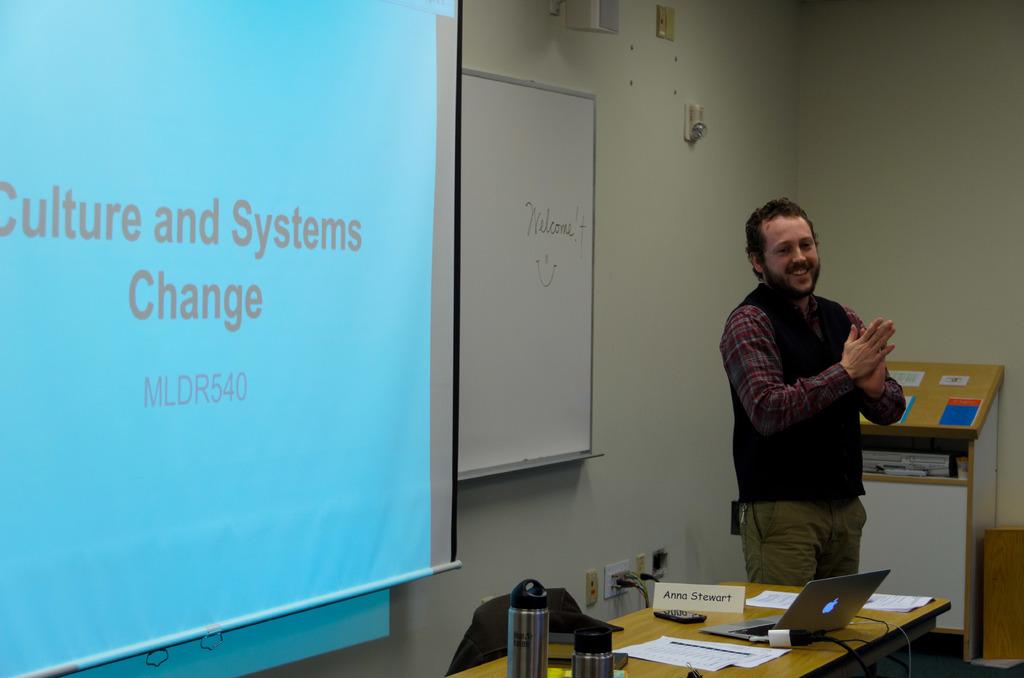What is the course number?
Keep it short and to the point. Mldr540. 